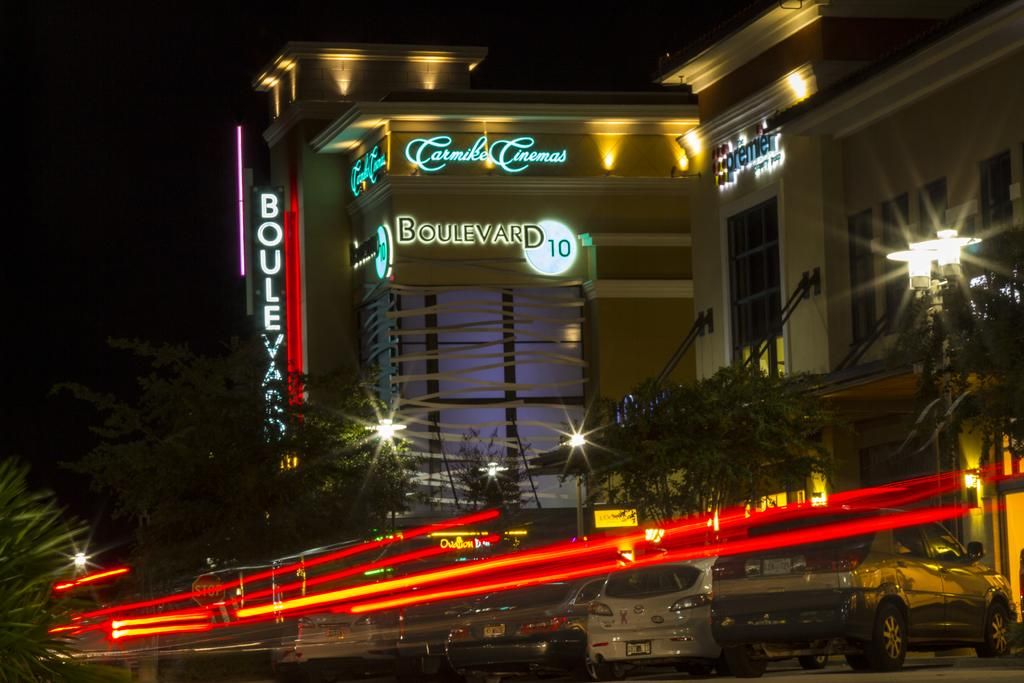What type of structures are present in the image? There are buildings with text in the image. What other elements can be seen in the image besides the buildings? There are trees, lights, and cars at the bottom of the image. What time of day was the image taken? The image was taken during night time. How many baby frogs can be seen wearing shoes in the image? There are no baby frogs or shoes present in the image. 